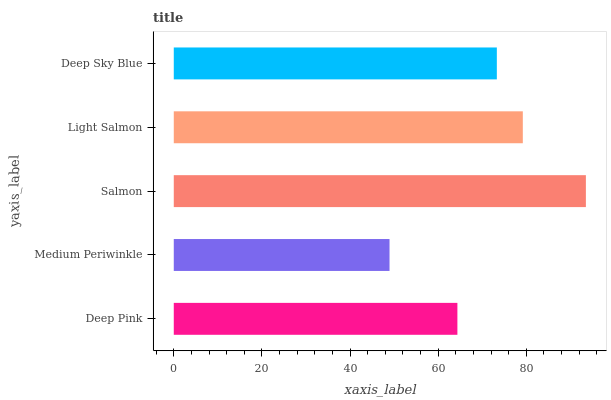Is Medium Periwinkle the minimum?
Answer yes or no. Yes. Is Salmon the maximum?
Answer yes or no. Yes. Is Salmon the minimum?
Answer yes or no. No. Is Medium Periwinkle the maximum?
Answer yes or no. No. Is Salmon greater than Medium Periwinkle?
Answer yes or no. Yes. Is Medium Periwinkle less than Salmon?
Answer yes or no. Yes. Is Medium Periwinkle greater than Salmon?
Answer yes or no. No. Is Salmon less than Medium Periwinkle?
Answer yes or no. No. Is Deep Sky Blue the high median?
Answer yes or no. Yes. Is Deep Sky Blue the low median?
Answer yes or no. Yes. Is Salmon the high median?
Answer yes or no. No. Is Salmon the low median?
Answer yes or no. No. 